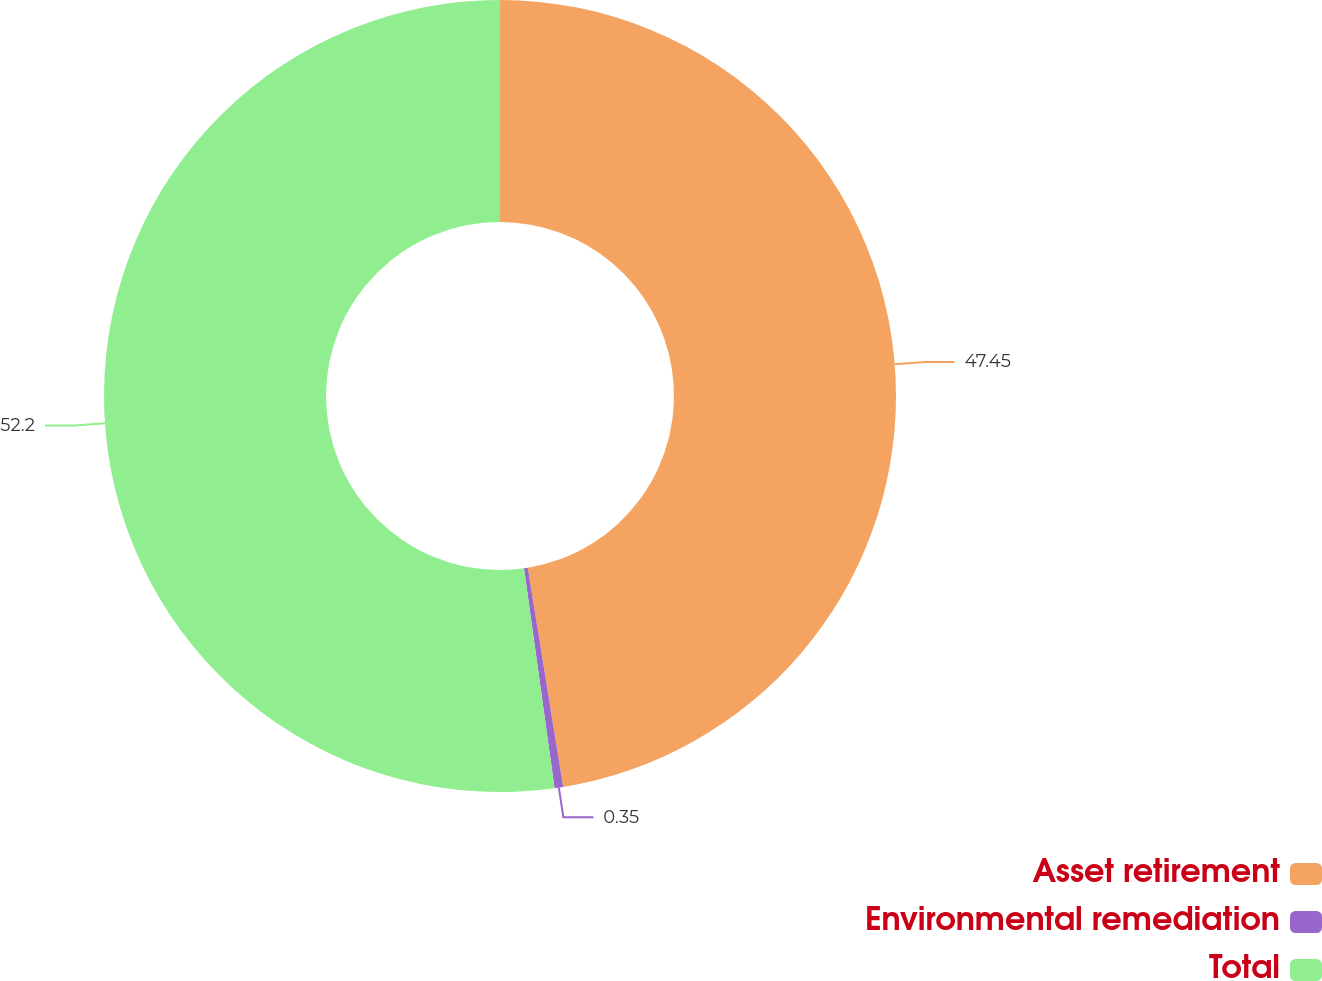<chart> <loc_0><loc_0><loc_500><loc_500><pie_chart><fcel>Asset retirement<fcel>Environmental remediation<fcel>Total<nl><fcel>47.45%<fcel>0.35%<fcel>52.2%<nl></chart> 